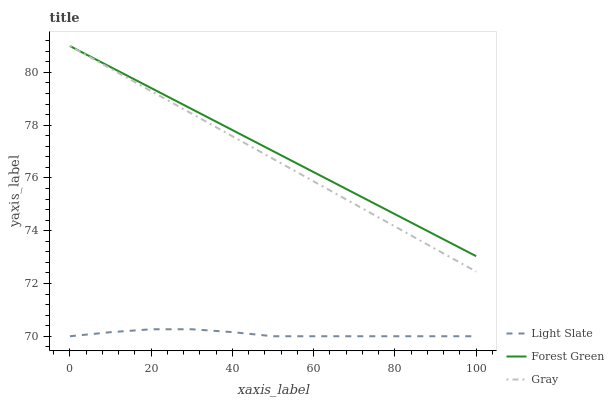Does Light Slate have the minimum area under the curve?
Answer yes or no. Yes. Does Forest Green have the maximum area under the curve?
Answer yes or no. Yes. Does Gray have the minimum area under the curve?
Answer yes or no. No. Does Gray have the maximum area under the curve?
Answer yes or no. No. Is Forest Green the smoothest?
Answer yes or no. Yes. Is Light Slate the roughest?
Answer yes or no. Yes. Is Gray the smoothest?
Answer yes or no. No. Is Gray the roughest?
Answer yes or no. No. Does Light Slate have the lowest value?
Answer yes or no. Yes. Does Gray have the lowest value?
Answer yes or no. No. Does Forest Green have the highest value?
Answer yes or no. Yes. Is Light Slate less than Gray?
Answer yes or no. Yes. Is Forest Green greater than Light Slate?
Answer yes or no. Yes. Does Forest Green intersect Gray?
Answer yes or no. Yes. Is Forest Green less than Gray?
Answer yes or no. No. Is Forest Green greater than Gray?
Answer yes or no. No. Does Light Slate intersect Gray?
Answer yes or no. No. 